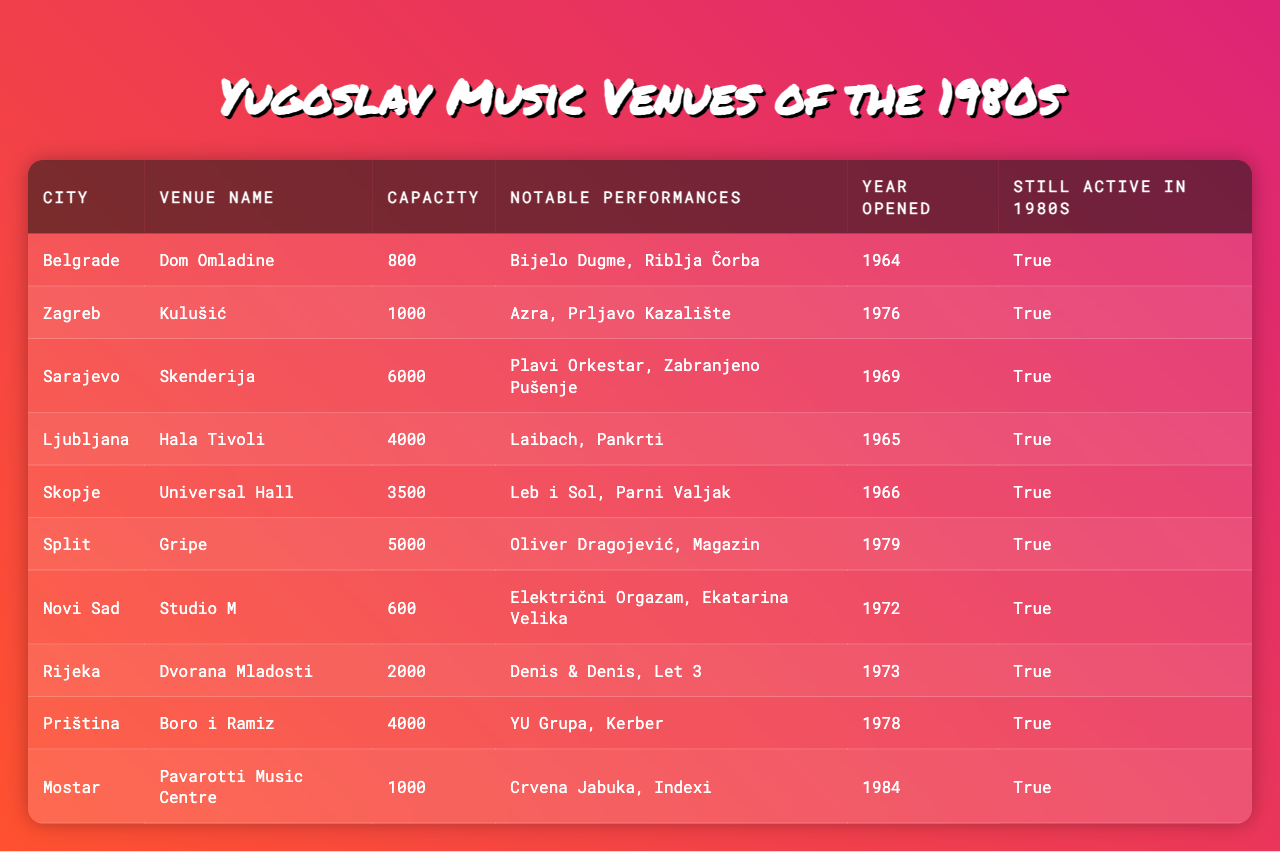What is the capacity of the "Kulušić" venue in Zagreb? The table lists each venue along with its respective capacity. For "Kulušić" in Zagreb, the capacity is specified as 1000.
Answer: 1000 Which venue has the largest capacity? By examining the capacity column, "Skenderija" in Sarajevo has the largest capacity listed at 6000.
Answer: 6000 Did "Bijelo Dugme" perform at a venue still active in the 1980s? "Bijelo Dugme" performed at "Dom Omladine," which is marked as still active in the 1980s in the table.
Answer: Yes How many venues listed are still active in the 1980s? All venues in the table are marked as still active during the 1980s. Therefore, the total is 10.
Answer: 10 What is the average capacity of the venues in the table? The capacities listed are 800, 1000, 6000, 4000, 3500, 5000, 600, 2000, 4000, and 1000. Summing these gives 15,000, and there are 10 venues, so the average is 15,000 / 10 = 1500.
Answer: 1500 Was "Dvorana Mladosti" opened before 1975? The opening year for "Dvorana Mladosti" is listed as 1973, which is indeed before 1975.
Answer: Yes Which city has a music venue that was opened in 1965? According to the table, both "Hala Tivoli" in Ljubljana and "Universal Hall" in Skopje were opened in 1965.
Answer: Ljubljana and Skopje Count the number of venues in cities starting with the letter 'S'. The cities "Sarajevo", "Skopje", and "Split" are starting with 'S', and each has one corresponding venue listed in the table, resulting in a total of 3.
Answer: 3 Which venue had a notable performance by "Oliver Dragojević"? "Gripe" in Split had a notable performance by "Oliver Dragojević" as shown in the notable performances column of the table.
Answer: Gripe Which city has a venue named after a famous tenor? The "Pavarotti Music Centre" in Mostar is named after the famous tenor Luciano Pavarotti.
Answer: Mostar 